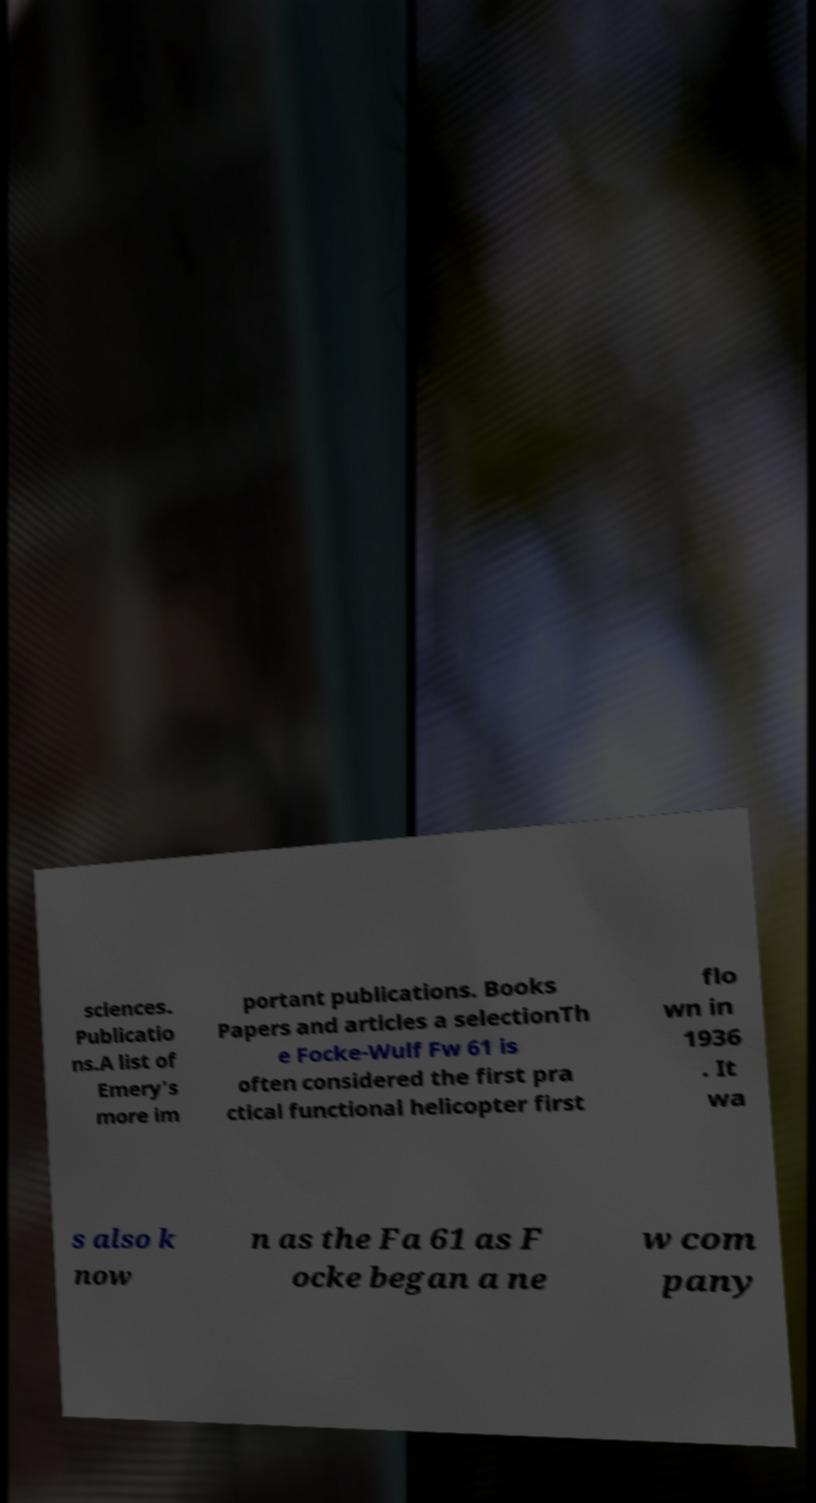I need the written content from this picture converted into text. Can you do that? sciences. Publicatio ns.A list of Emery's more im portant publications. Books Papers and articles a selectionTh e Focke-Wulf Fw 61 is often considered the first pra ctical functional helicopter first flo wn in 1936 . It wa s also k now n as the Fa 61 as F ocke began a ne w com pany 